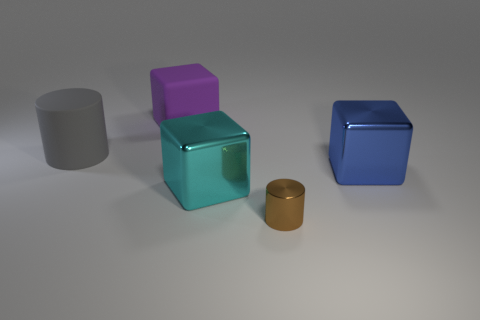Add 3 tiny brown cylinders. How many objects exist? 8 Subtract all cylinders. How many objects are left? 3 Add 4 big matte blocks. How many big matte blocks exist? 5 Subtract 1 blue blocks. How many objects are left? 4 Subtract all small yellow blocks. Subtract all gray matte cylinders. How many objects are left? 4 Add 3 gray cylinders. How many gray cylinders are left? 4 